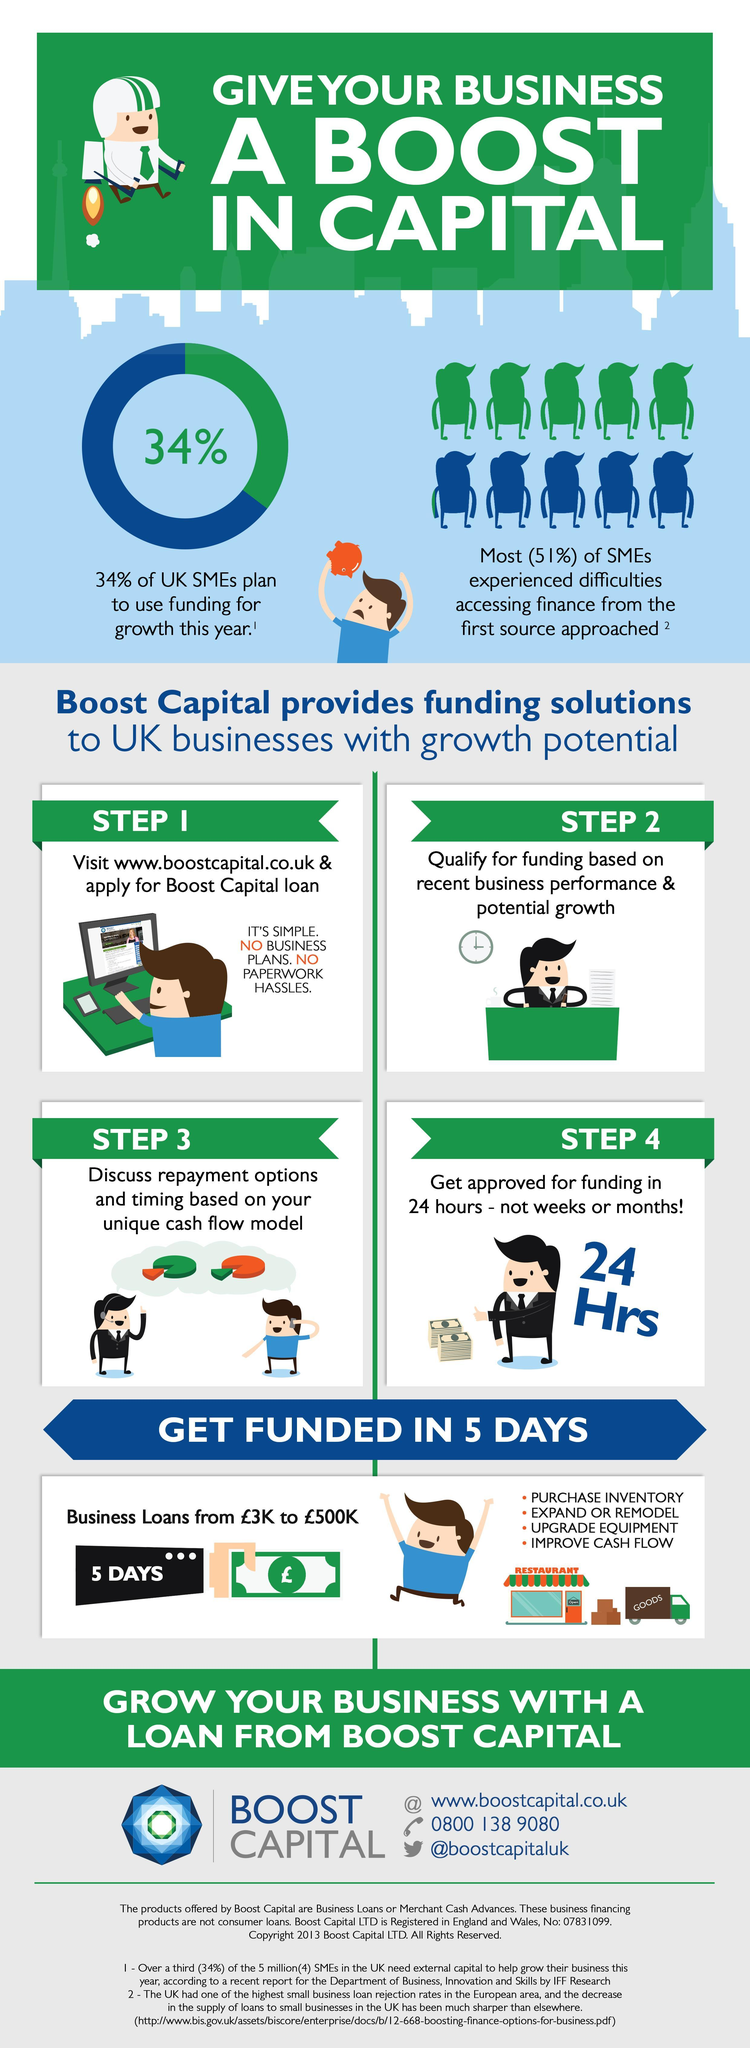How long it takes for Boost Capital to credit the loan amount in cash?
Answer the question with a short phrase. 5 days What percentage of small medium enterprises in UK faced challenges while trying to get loan from financial institutions other than Boost Capital? 51% What is the criteria for Boost Capital to approve the business loan? recent business performance & potential growth 